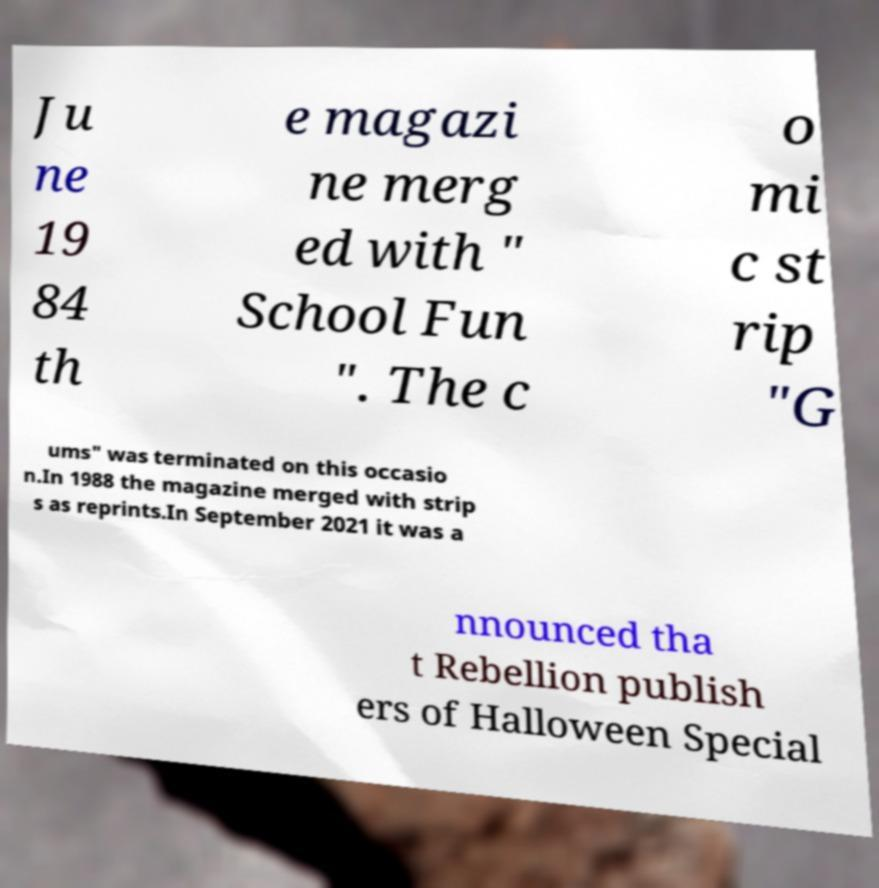I need the written content from this picture converted into text. Can you do that? Ju ne 19 84 th e magazi ne merg ed with " School Fun ". The c o mi c st rip "G ums" was terminated on this occasio n.In 1988 the magazine merged with strip s as reprints.In September 2021 it was a nnounced tha t Rebellion publish ers of Halloween Special 